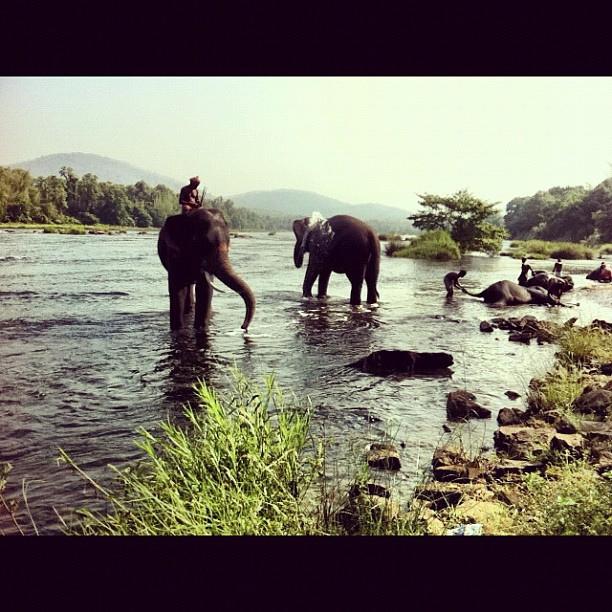Are these elephants in the wild?
Give a very brief answer. Yes. What is on the elephant's back?
Short answer required. Person. How is following who?
Write a very short answer. Elephant following elephant. What color is the elephant?
Concise answer only. Gray. Is it mid day?
Write a very short answer. Yes. Are there any elephants laying down?
Short answer required. Yes. 